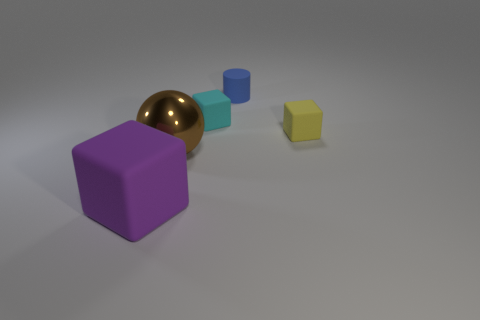What could be the possible material composition of these objects? Based on the way the light reflects off the surfaces, the purple and yellow cubes seem to have a matte finish, suggesting a possible plastic or painted wood material. The gold sphere has a reflective surface that might indicate a metallic material, and the cyan cube, with a less reflective surface than the sphere, could also be made of a matte or slightly glossy plastic. 